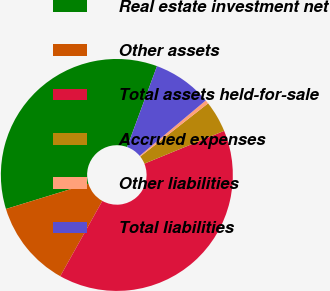Convert chart. <chart><loc_0><loc_0><loc_500><loc_500><pie_chart><fcel>Real estate investment net<fcel>Other assets<fcel>Total assets held-for-sale<fcel>Accrued expenses<fcel>Other liabilities<fcel>Total liabilities<nl><fcel>35.36%<fcel>12.15%<fcel>39.31%<fcel>4.39%<fcel>0.51%<fcel>8.27%<nl></chart> 